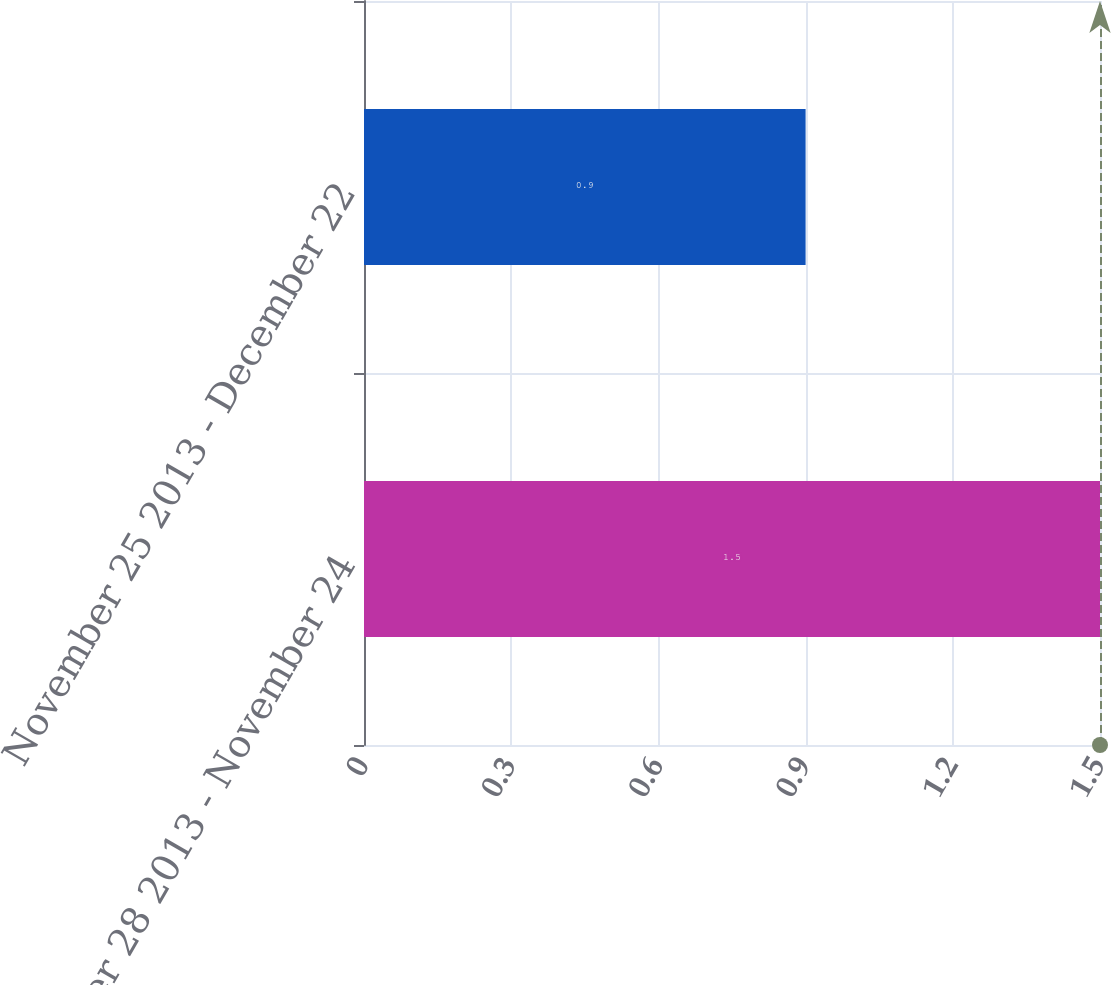Convert chart to OTSL. <chart><loc_0><loc_0><loc_500><loc_500><bar_chart><fcel>October 28 2013 - November 24<fcel>November 25 2013 - December 22<nl><fcel>1.5<fcel>0.9<nl></chart> 